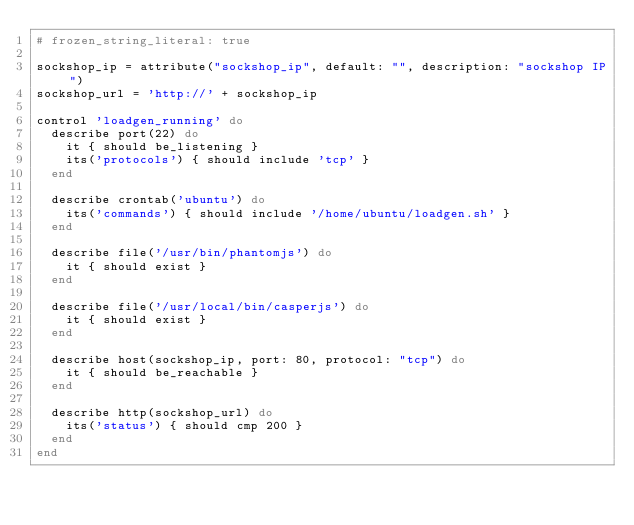<code> <loc_0><loc_0><loc_500><loc_500><_Ruby_># frozen_string_literal: true

sockshop_ip = attribute("sockshop_ip", default: "", description: "sockshop IP")
sockshop_url = 'http://' + sockshop_ip

control 'loadgen_running' do
  describe port(22) do
    it { should be_listening }
    its('protocols') { should include 'tcp' }
  end

  describe crontab('ubuntu') do
    its('commands') { should include '/home/ubuntu/loadgen.sh' }
  end

  describe file('/usr/bin/phantomjs') do
    it { should exist }
  end

  describe file('/usr/local/bin/casperjs') do
    it { should exist }
  end

  describe host(sockshop_ip, port: 80, protocol: "tcp") do
    it { should be_reachable }
  end

  describe http(sockshop_url) do
    its('status') { should cmp 200 }
  end
end
</code> 